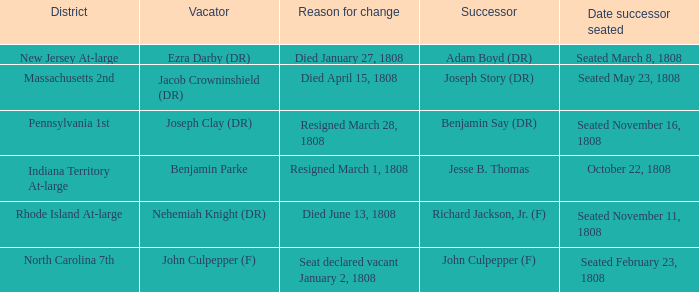How many vacators have October 22, 1808 as date successor seated? 1.0. 